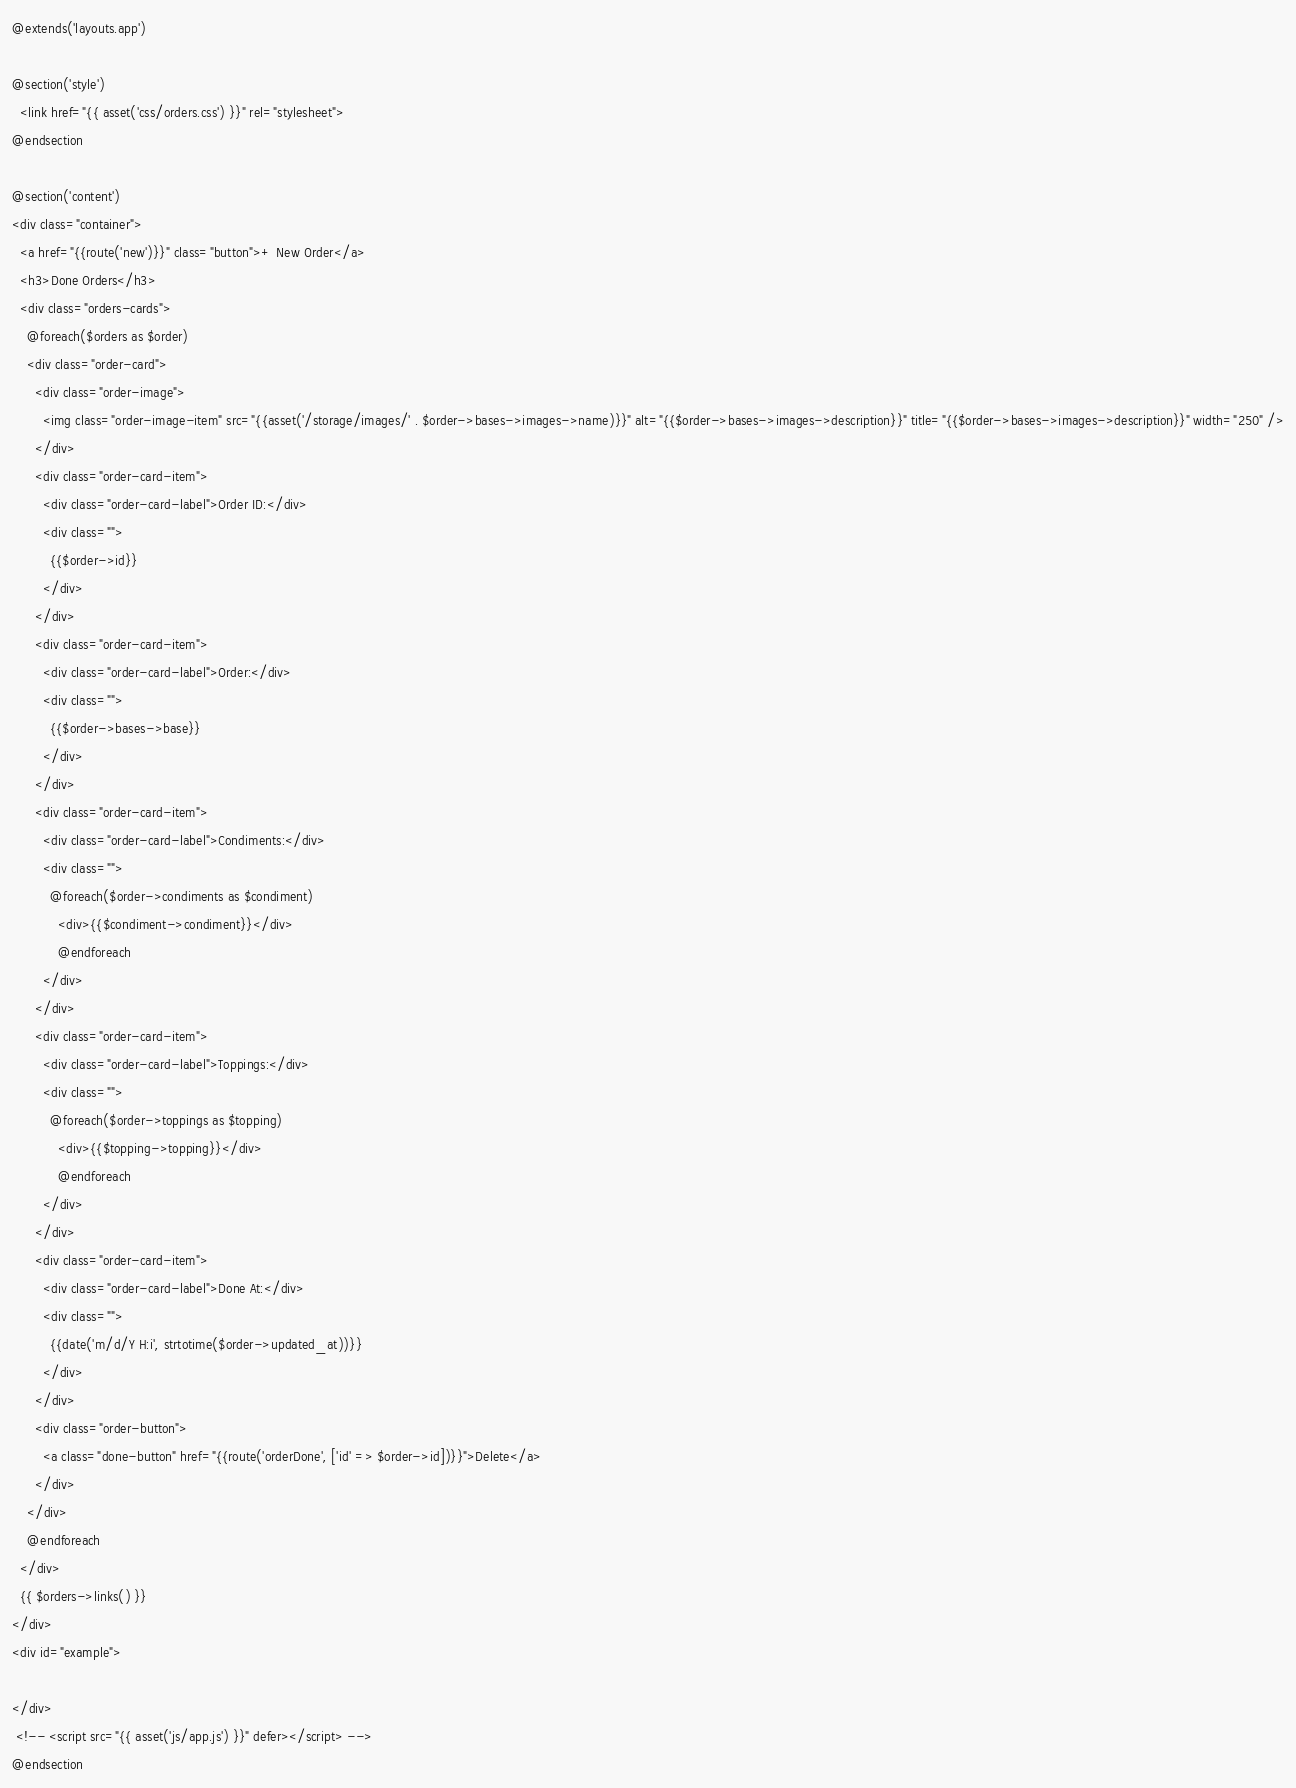Convert code to text. <code><loc_0><loc_0><loc_500><loc_500><_PHP_>@extends('layouts.app')

@section('style')
  <link href="{{ asset('css/orders.css') }}" rel="stylesheet">
@endsection

@section('content')
<div class="container">
  <a href="{{route('new')}}" class="button">+ New Order</a>
  <h3>Done Orders</h3>
  <div class="orders-cards">
    @foreach($orders as $order)
    <div class="order-card">
      <div class="order-image">
        <img class="order-image-item" src="{{asset('/storage/images/' . $order->bases->images->name)}}" alt="{{$order->bases->images->description}}" title="{{$order->bases->images->description}}" width="250" />
      </div>
      <div class="order-card-item">
        <div class="order-card-label">Order ID:</div>
        <div class="">
          {{$order->id}}
        </div>
      </div>
      <div class="order-card-item">
        <div class="order-card-label">Order:</div>
        <div class="">
          {{$order->bases->base}}
        </div>
      </div>
      <div class="order-card-item">
        <div class="order-card-label">Condiments:</div>
        <div class="">
          @foreach($order->condiments as $condiment)
            <div>{{$condiment->condiment}}</div>
            @endforeach
        </div>
      </div>
      <div class="order-card-item">
        <div class="order-card-label">Toppings:</div>
        <div class="">
          @foreach($order->toppings as $topping)
            <div>{{$topping->topping}}</div>
            @endforeach
        </div>
      </div>
      <div class="order-card-item">
        <div class="order-card-label">Done At:</div>
        <div class="">
          {{date('m/d/Y H:i', strtotime($order->updated_at))}}
        </div>
      </div>
      <div class="order-button">
        <a class="done-button" href="{{route('orderDone', ['id' => $order->id])}}">Delete</a>
      </div>
    </div>
    @endforeach
  </div>
  {{ $orders->links() }}
</div>
<div id="example">

</div>
 <!-- <script src="{{ asset('js/app.js') }}" defer></script> -->
@endsection
</code> 